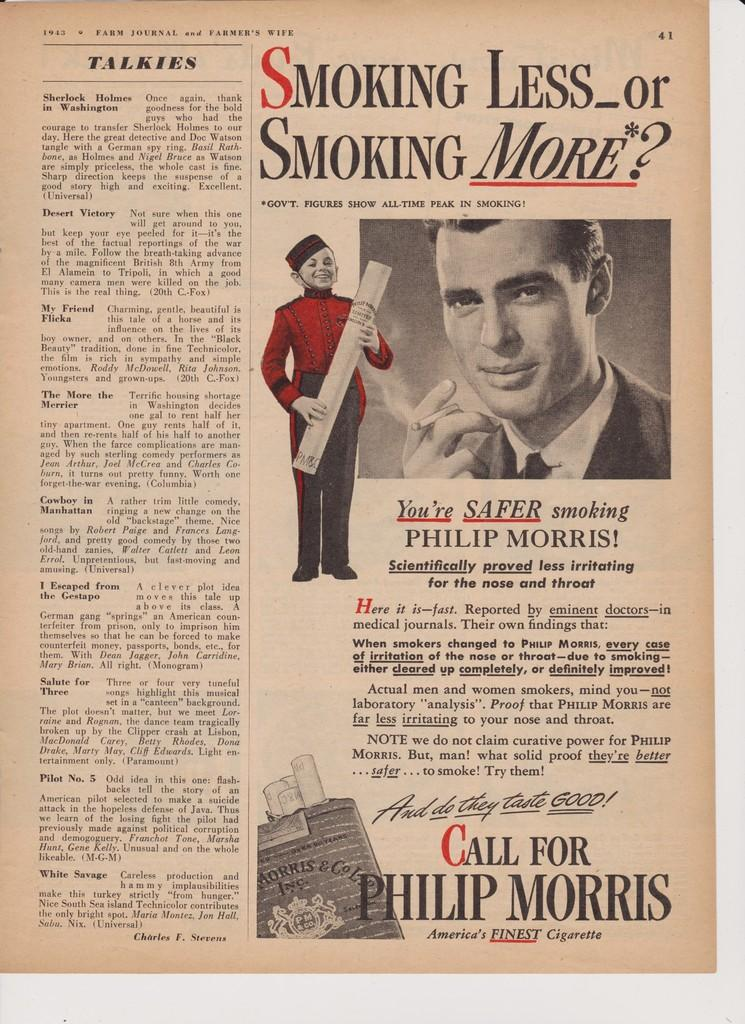What type of publication does the image resemble? The image resembles a newspaper. What can be seen in the middle of the image? There are images of humans in the middle of the image. Where is the text located in the image? There is text on the left side of the image. What new writing technique was discovered by the humans in the image? There is no mention of a new writing technique or any discovery in the image; it simply features images of humans and text. 